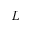<formula> <loc_0><loc_0><loc_500><loc_500>L</formula> 